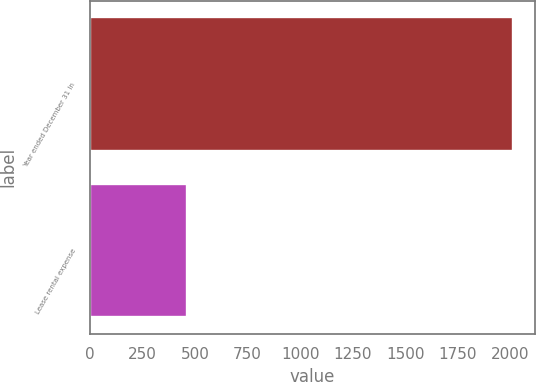Convert chart to OTSL. <chart><loc_0><loc_0><loc_500><loc_500><bar_chart><fcel>Year ended December 31 In<fcel>Lease rental expense<nl><fcel>2015<fcel>460<nl></chart> 